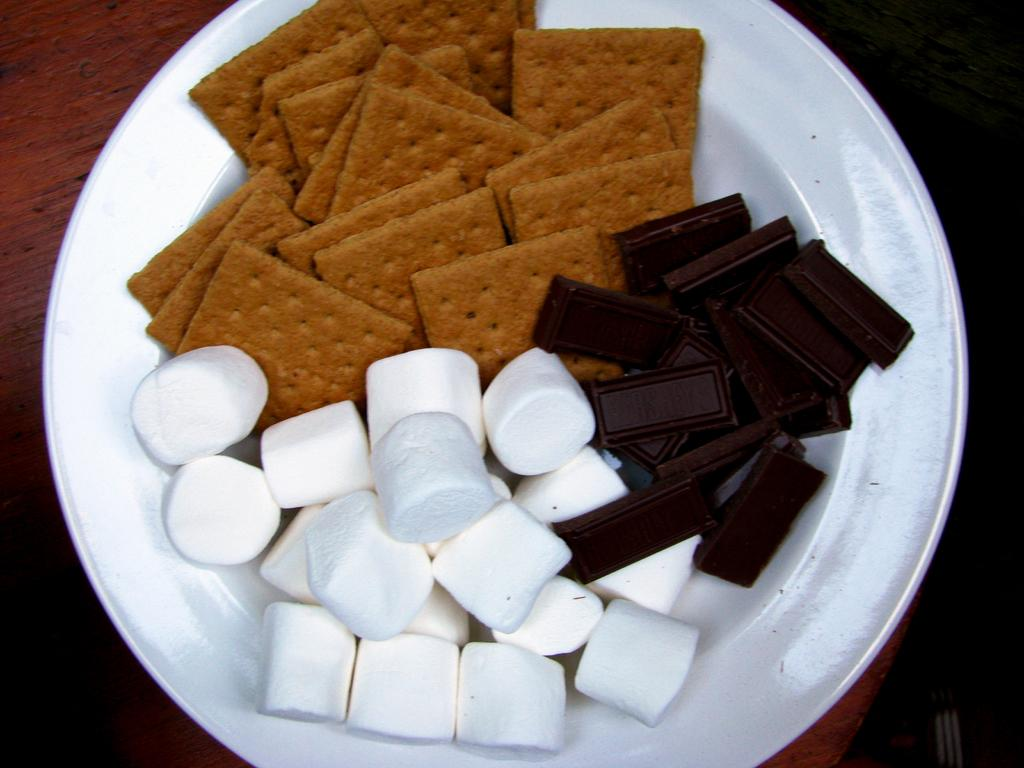What type of food items can be seen in the image? There are biscuits, dark chocolate, and marshmallow in the image. How are the food items arranged in the image? The items are on a plate in the image. What type of surface is the plate placed on? There is a wooden table in the image. How many tents are visible in the image? There are no tents present in the image. Can you describe the footwear being worn by the people in the image? There are no people or footwear visible in the image; it only features biscuits, dark chocolate, marshmallow, a plate, and a wooden table. 